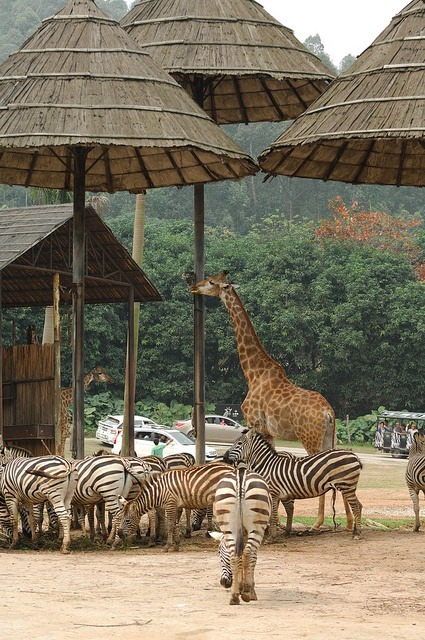Describe the objects in this image and their specific colors. I can see umbrella in darkgray, gray, maroon, and black tones, umbrella in darkgray, gray, and black tones, umbrella in darkgray, gray, and black tones, giraffe in darkgray, maroon, gray, tan, and brown tones, and zebra in darkgray, black, maroon, and tan tones in this image. 